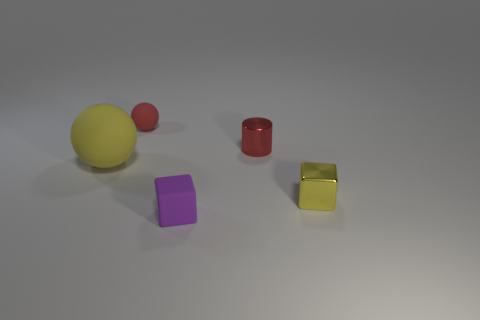Are the yellow object that is to the left of the small purple object and the purple block made of the same material?
Offer a very short reply. Yes. Is the number of small red objects in front of the purple cube the same as the number of red cylinders on the left side of the cylinder?
Keep it short and to the point. Yes. Are there any other things that are the same size as the shiny cube?
Your answer should be very brief. Yes. There is another object that is the same shape as the big yellow thing; what material is it?
Ensure brevity in your answer.  Rubber. Is there a small shiny cube in front of the small shiny block that is right of the matte sphere in front of the tiny red metal thing?
Provide a succinct answer. No. Do the rubber thing that is behind the big yellow object and the yellow object left of the tiny yellow thing have the same shape?
Keep it short and to the point. Yes. Are there more red shiny cylinders that are right of the tiny cylinder than tiny matte cubes?
Make the answer very short. No. How many objects are either small blue objects or tiny metal blocks?
Give a very brief answer. 1. The metallic cylinder is what color?
Your response must be concise. Red. What number of other things are the same color as the metallic cube?
Keep it short and to the point. 1. 